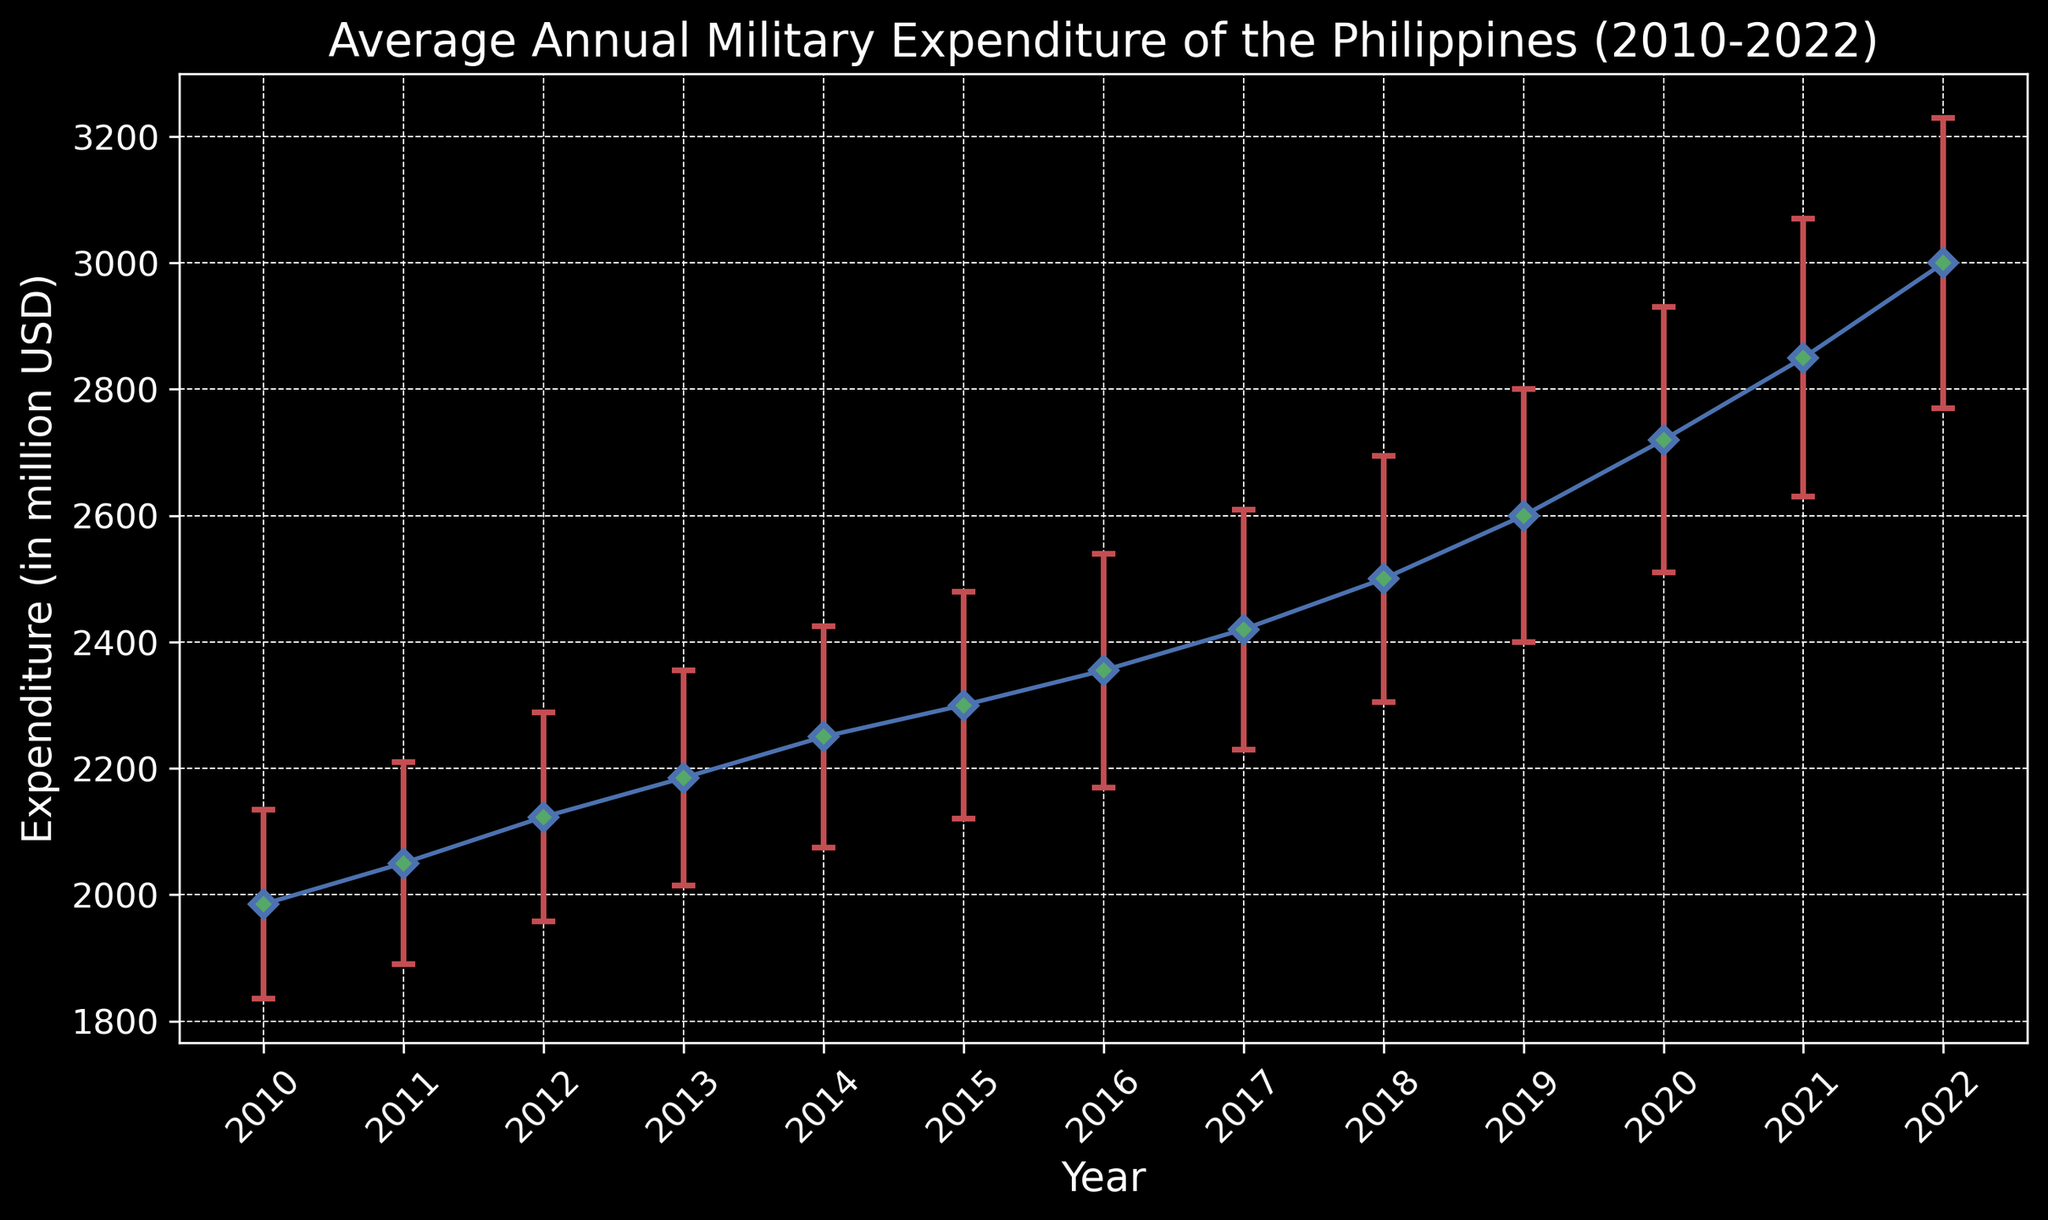What is the average annual military expenditure of the Philippines in 2012? Look at the data point for 2012 on the plot. The y-axis shows the expenditure value, which is 2123 million USD.
Answer: 2123 million USD In which year did the Philippines' average annual military expenditure exceed 2500 million USD for the first time? Identify the first year the expenditure data point goes above 2500 million USD. The expenditure exceeds 2500 million USD in 2019.
Answer: 2019 How much did the average annual military expenditure increase from 2010 to 2022? Subtract the 2010 expenditure value from the 2022 expenditure value: 3000 million USD - 1985 million USD = 1015 million USD.
Answer: 1015 million USD Which year had the highest average annual military expenditure? Examine the data points to find the highest expenditure value, which occurs in 2022 at 3000 million USD.
Answer: 2022 What is the range of the error margin for the average annual military expenditure in 2015? Identify the error margin for 2015, which is 180 million USD. The range is from (2300 - 180) million USD to (2300 + 180) million USD, i.e., 2120 million USD to 2480 million USD.
Answer: 2120 to 2480 million USD Between 2010 and 2022, which year had the smallest growth in military expenditure compared to the previous year? Calculate the year-over-year differences and find the smallest one. The smallest growth occurs between 2017 and 2018, where the increase is 80 million USD (2500 - 2420).
Answer: 2018 By what percentage did the Philippines' average annual military expenditure grow from 2020 to 2022? Calculate the percentage growth: ((3000 - 2720) / 2720) * 100 ≈ 10.3%.
Answer: 10.3% Compare the error margins between 2010 and 2022. How much larger is the error margin in 2022 compared to 2010? Subtract the 2010 error margin from the 2022 error margin: 230 million USD - 150 million USD = 80 million USD.
Answer: 80 million USD Which year had a higher average annual military expenditure: 2014 or 2015? Compare the expenditure values for 2014 and 2015. The expenditure in 2014 is 2250 million USD, and in 2015 it is 2300 million USD, so 2015 had a higher expenditure.
Answer: 2015 What is the average military expenditure over the entire period from 2010 to 2022? Sum all the expenditure values and divide by the number of years: (1985 + 2050 + 2123 + 2185 + 2250 + 2300 + 2355 + 2420 + 2500 + 2600 + 2720 + 2850 + 3000) / 13 ≈ 2418.5 million USD.
Answer: 2418.5 million USD 